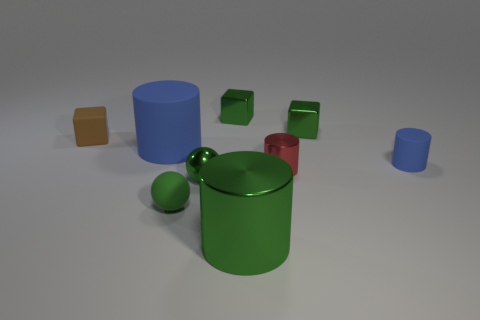Subtract all cyan cylinders. Subtract all purple spheres. How many cylinders are left? 4 Add 1 big blue objects. How many objects exist? 10 Subtract all spheres. How many objects are left? 7 Subtract 1 green cubes. How many objects are left? 8 Subtract all big green cylinders. Subtract all green spheres. How many objects are left? 6 Add 8 small red shiny cylinders. How many small red shiny cylinders are left? 9 Add 1 large yellow metallic cylinders. How many large yellow metallic cylinders exist? 1 